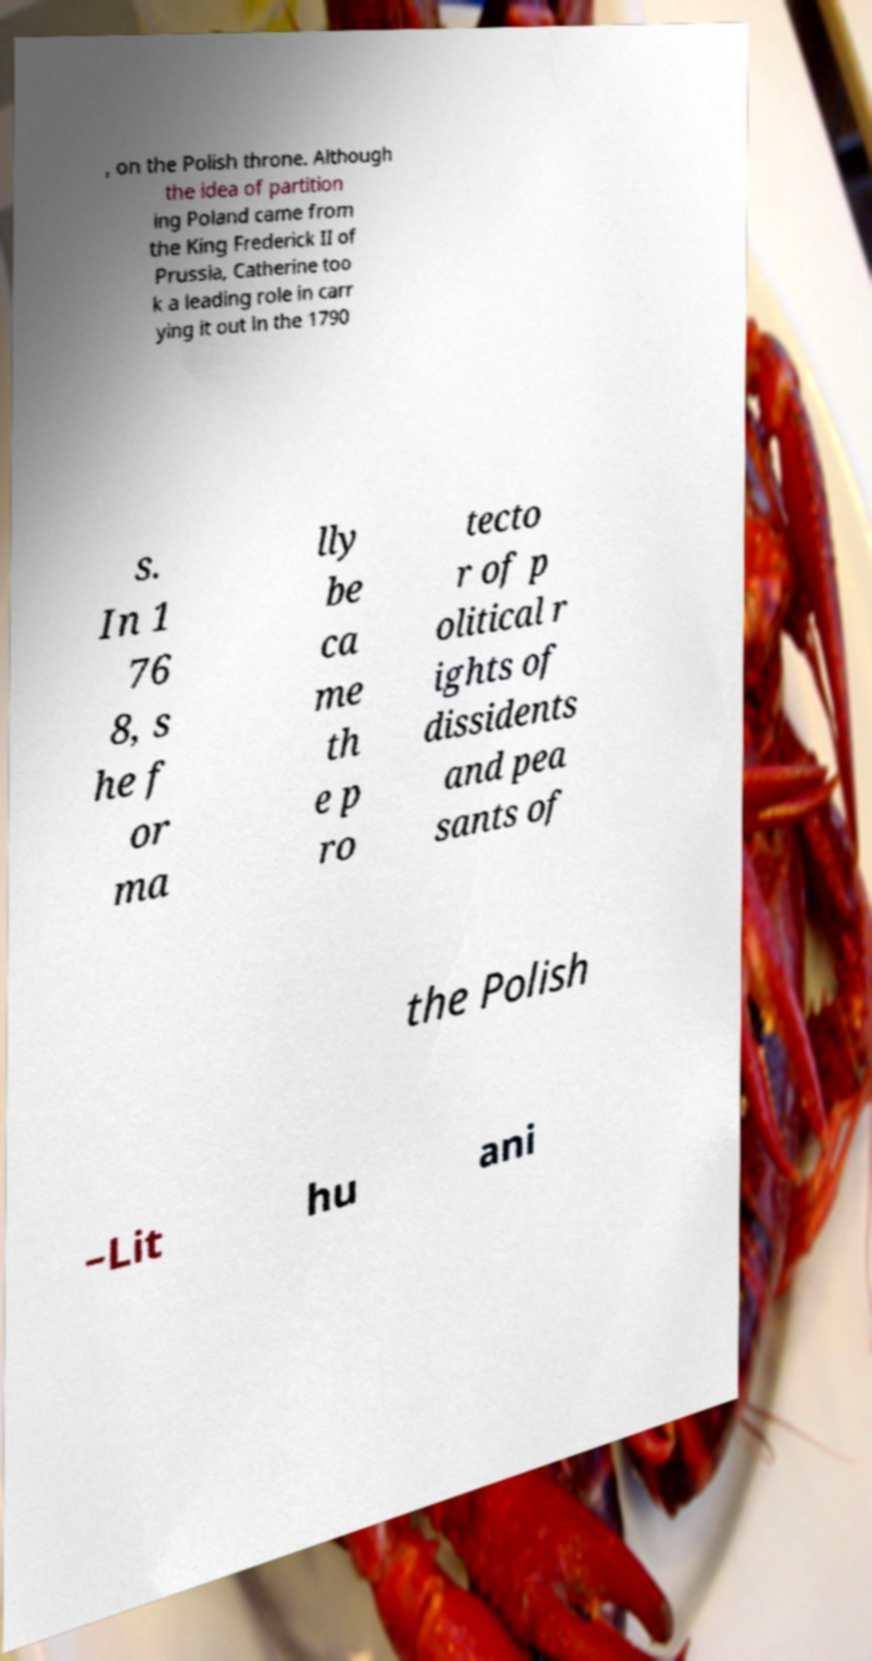What messages or text are displayed in this image? I need them in a readable, typed format. , on the Polish throne. Although the idea of partition ing Poland came from the King Frederick II of Prussia, Catherine too k a leading role in carr ying it out in the 1790 s. In 1 76 8, s he f or ma lly be ca me th e p ro tecto r of p olitical r ights of dissidents and pea sants of the Polish –Lit hu ani 